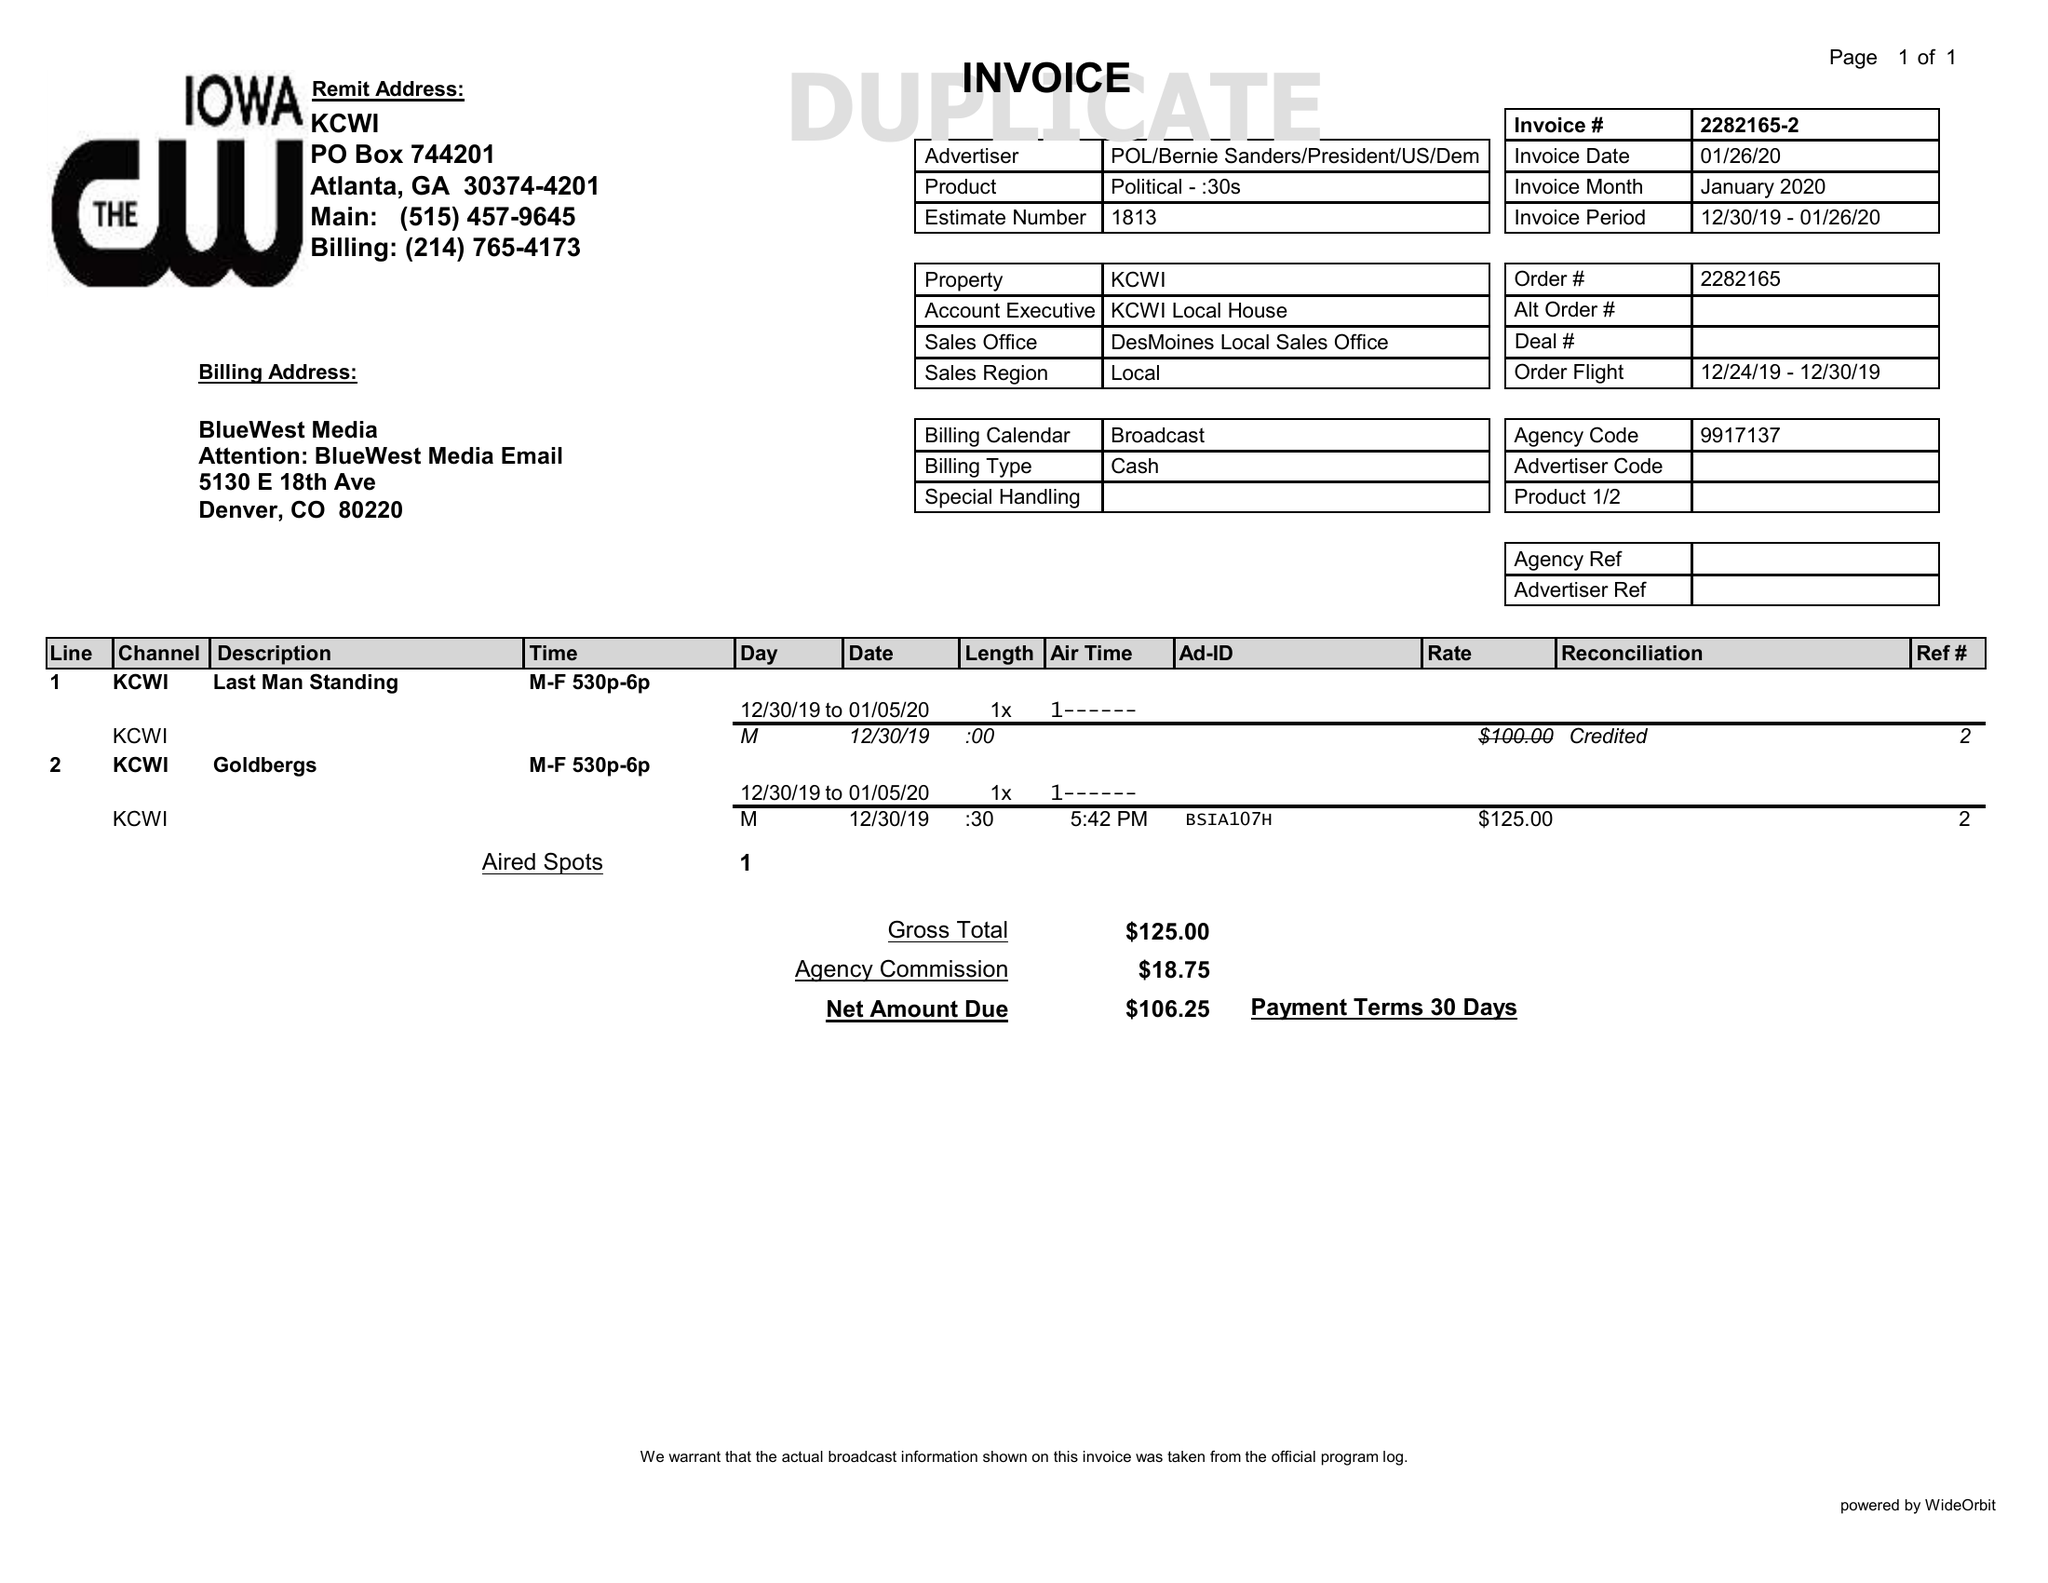What is the value for the gross_amount?
Answer the question using a single word or phrase. 125.00 